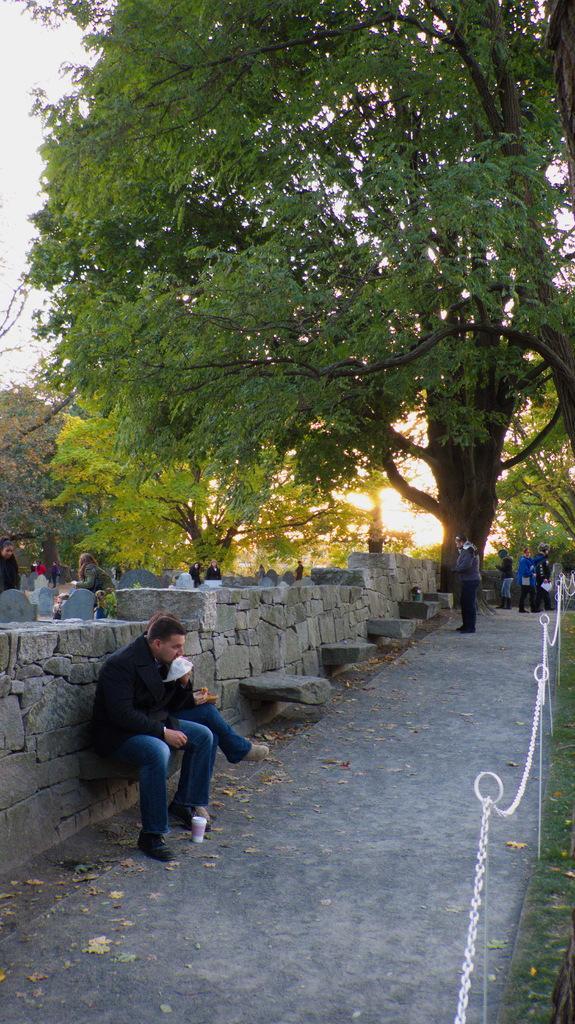How would you summarize this image in a sentence or two? In the image there is a tall tree and beside the tree there is a wall and in front of the wall there are some stones and a person is sitting on one of the stones, on the right side there are few rods attached with the chains and in the background there are many other people standing in front of the wall and behind them there are a lot of trees. 